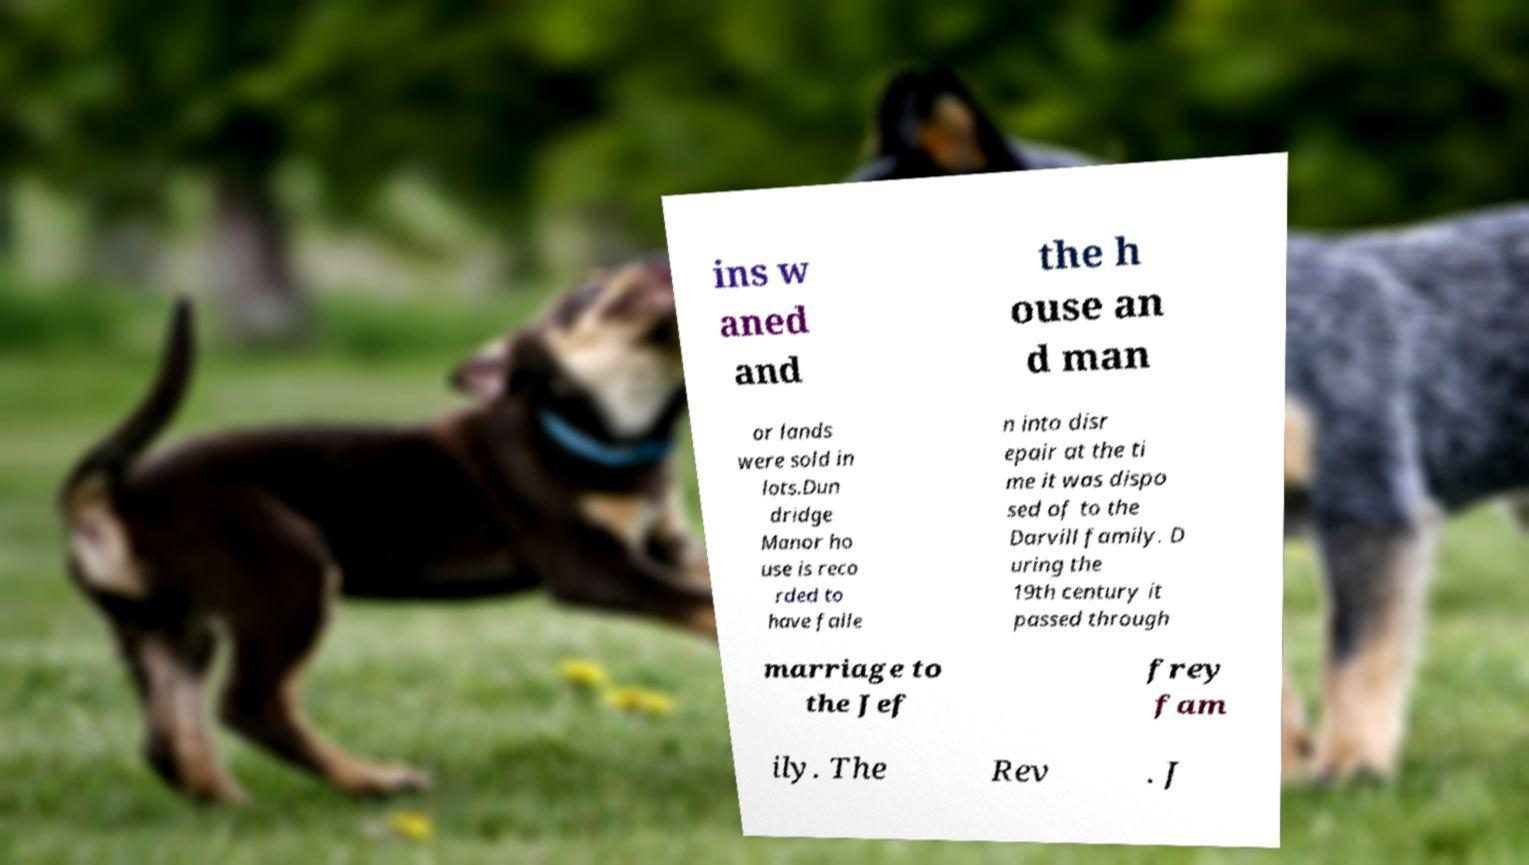Can you read and provide the text displayed in the image?This photo seems to have some interesting text. Can you extract and type it out for me? ins w aned and the h ouse an d man or lands were sold in lots.Dun dridge Manor ho use is reco rded to have falle n into disr epair at the ti me it was dispo sed of to the Darvill family. D uring the 19th century it passed through marriage to the Jef frey fam ily. The Rev . J 